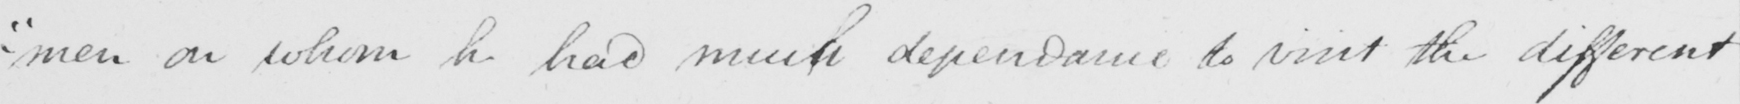What text is written in this handwritten line? - " men on whom he had much dependance to visit the different 